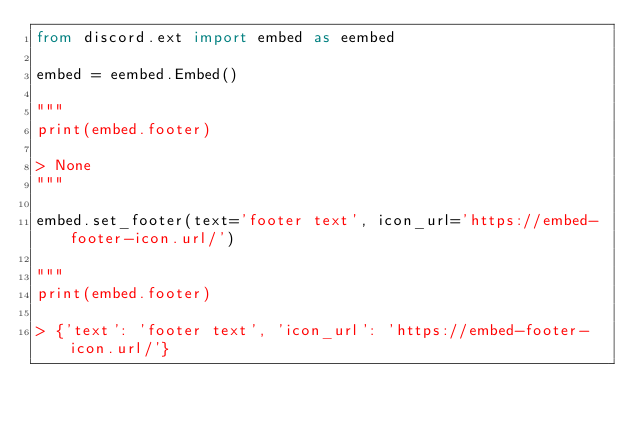<code> <loc_0><loc_0><loc_500><loc_500><_Python_>from discord.ext import embed as eembed

embed = eembed.Embed()

"""
print(embed.footer)

> None
"""

embed.set_footer(text='footer text', icon_url='https://embed-footer-icon.url/')

"""
print(embed.footer)

> {'text': 'footer text', 'icon_url': 'https://embed-footer-icon.url/'}
</code> 